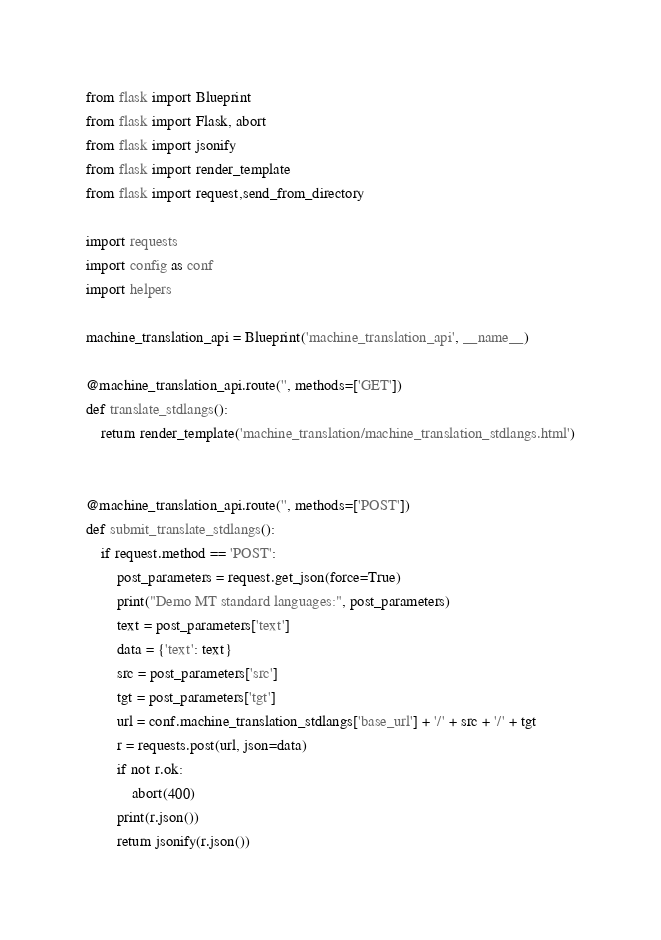Convert code to text. <code><loc_0><loc_0><loc_500><loc_500><_Python_>from flask import Blueprint
from flask import Flask, abort
from flask import jsonify
from flask import render_template
from flask import request,send_from_directory

import requests
import config as conf
import helpers

machine_translation_api = Blueprint('machine_translation_api', __name__)

@machine_translation_api.route('', methods=['GET'])
def translate_stdlangs():
    return render_template('machine_translation/machine_translation_stdlangs.html')


@machine_translation_api.route('', methods=['POST'])
def submit_translate_stdlangs():
    if request.method == 'POST':
        post_parameters = request.get_json(force=True)
        print("Demo MT standard languages:", post_parameters)
        text = post_parameters['text']
        data = {'text': text}
        src = post_parameters['src']
        tgt = post_parameters['tgt']
        url = conf.machine_translation_stdlangs['base_url'] + '/' + src + '/' + tgt
        r = requests.post(url, json=data)
        if not r.ok:
            abort(400)
        print(r.json())
        return jsonify(r.json())</code> 